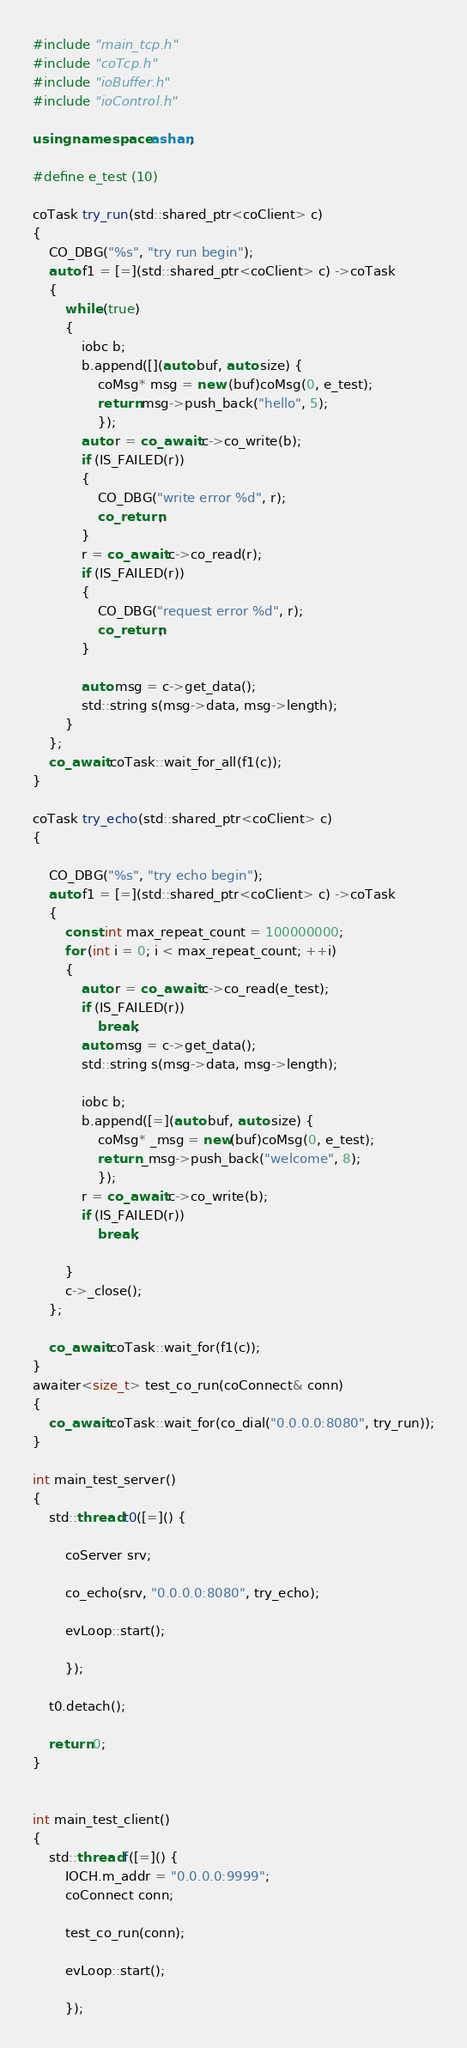<code> <loc_0><loc_0><loc_500><loc_500><_C++_>#include "main_tcp.h"
#include "coTcp.h"
#include "ioBuffer.h"
#include "ioControl.h"

using namespace ashan;

#define e_test (10)

coTask try_run(std::shared_ptr<coClient> c)
{	
	CO_DBG("%s", "try run begin");
	auto f1 = [=](std::shared_ptr<coClient> c) ->coTask
	{
		while (true)
		{
			iobc b;
			b.append([](auto buf, auto size) {
				coMsg* msg = new (buf)coMsg(0, e_test);
				return msg->push_back("hello", 5);
				});		
			auto r = co_await c->co_write(b);			
			if (IS_FAILED(r))
			{
				CO_DBG("write error %d", r);
				co_return;
			}
			r = co_await c->co_read(r);
			if (IS_FAILED(r))
			{
				CO_DBG("request error %d", r);
				co_return;
			}

			auto msg = c->get_data();
			std::string s(msg->data, msg->length);
		}
	};
	co_await coTask::wait_for_all(f1(c));
}

coTask try_echo(std::shared_ptr<coClient> c)
{	
	
	CO_DBG("%s", "try echo begin");
	auto f1 = [=](std::shared_ptr<coClient> c) ->coTask
	{		
		const int max_repeat_count = 100000000;
		for (int i = 0; i < max_repeat_count; ++i)
		{			
			auto r = co_await c->co_read(e_test);
			if (IS_FAILED(r))
				break;
			auto msg = c->get_data();
			std::string s(msg->data, msg->length);			

			iobc b;
			b.append([=](auto buf, auto size) {
				coMsg* _msg = new(buf)coMsg(0, e_test);
				return _msg->push_back("welcome", 8);
				});
			r = co_await c->co_write(b);
			if (IS_FAILED(r))
				break;

		}
		c->_close();	
	};

	co_await coTask::wait_for(f1(c));
}
awaiter<size_t> test_co_run(coConnect& conn)
{
	co_await coTask::wait_for(co_dial("0.0.0.0:8080", try_run));
}

int main_test_server()
{
	std::thread t0([=]() {

		coServer srv;		

		co_echo(srv, "0.0.0.0:8080", try_echo);

		evLoop::start();

		});

	t0.detach();

	return 0;
}


int main_test_client()
{
	std::thread f([=]() {
		IOCH.m_addr = "0.0.0.0:9999";		
		coConnect conn;	

		test_co_run(conn);

		evLoop::start();

		});
</code> 